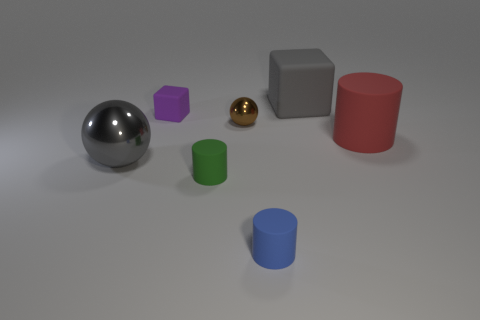What number of objects are either things behind the purple matte object or metallic objects behind the large gray shiny sphere?
Offer a very short reply. 2. What color is the shiny ball in front of the shiny sphere on the right side of the shiny sphere in front of the brown shiny thing?
Your answer should be very brief. Gray. Are there any tiny cyan things that have the same shape as the brown metal thing?
Provide a short and direct response. No. What number of small purple matte objects are there?
Ensure brevity in your answer.  1. The red matte thing has what shape?
Your answer should be compact. Cylinder. How many green matte objects are the same size as the brown thing?
Your answer should be compact. 1. Do the small green thing and the small brown thing have the same shape?
Make the answer very short. No. What color is the matte block that is in front of the big gray cube behind the big rubber cylinder?
Keep it short and to the point. Purple. What size is the matte cylinder that is to the left of the big cube and to the right of the small green object?
Your response must be concise. Small. Are there any other things that are the same color as the small ball?
Give a very brief answer. No. 